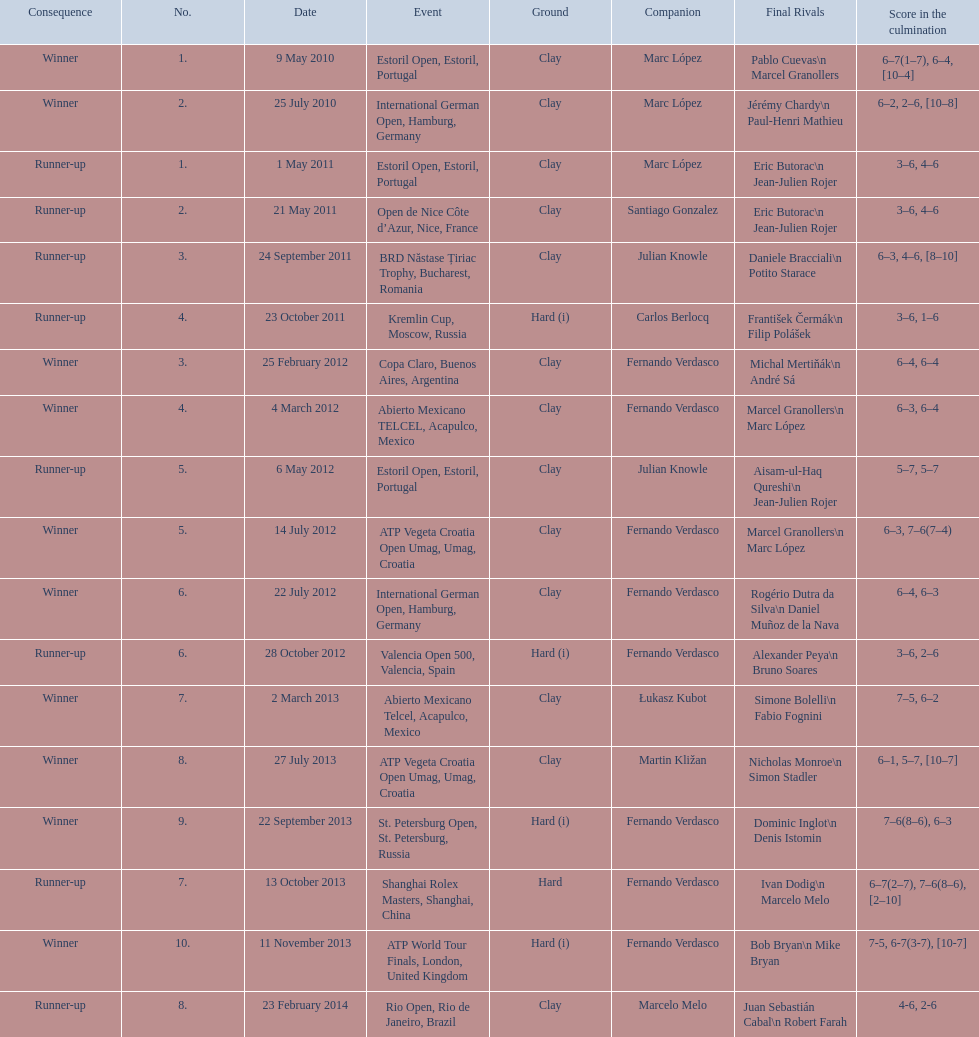How many tournaments has this player won in his career so far? 10. 